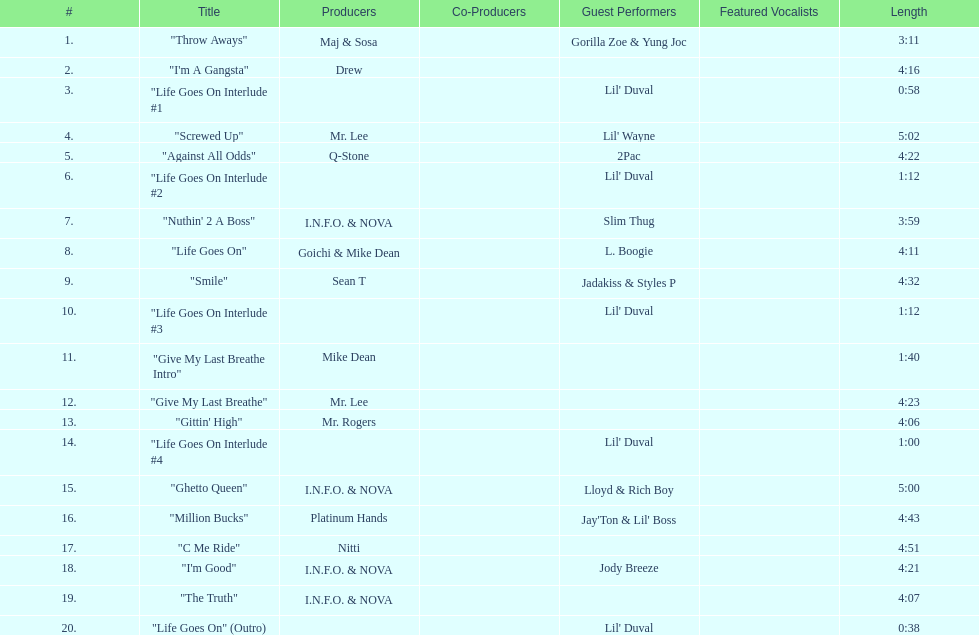What is the last track produced by mr. lee? "Give My Last Breathe". 